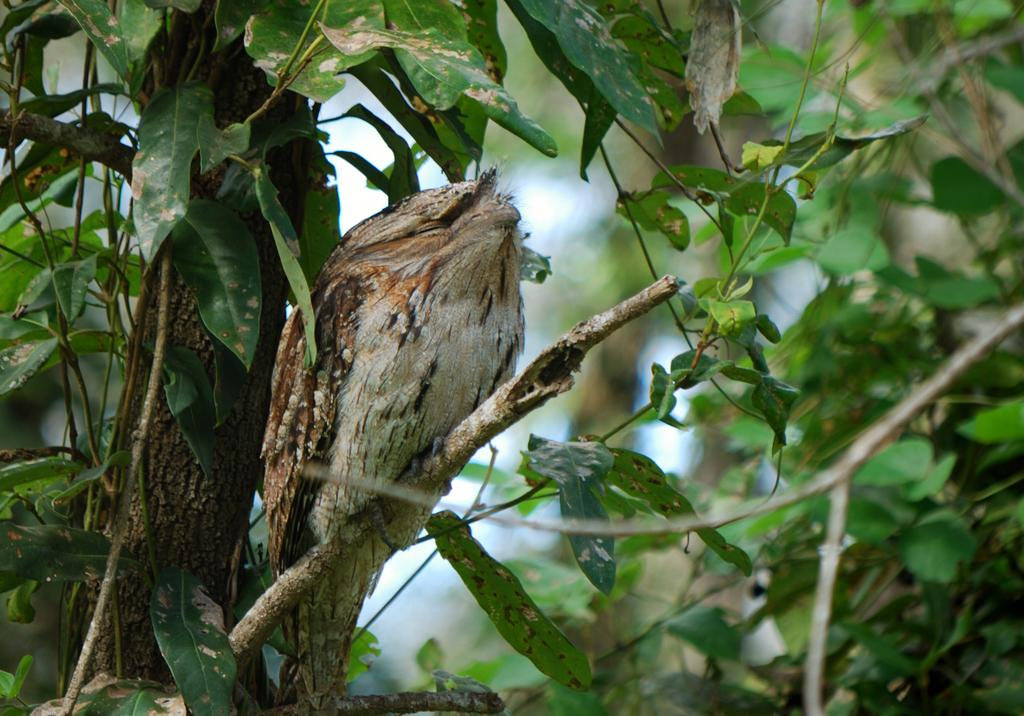What type of animal can be seen in the image? There is a bird in the image. Where is the bird located? The bird is on a branch of a tree. What can be observed about the tree in the image? The tree has leaves. How would you describe the background of the image? The background of the image is blurry. What type of box is the bird using to build its nest in the image? There is no box present in the image, and the bird is not building a nest. 